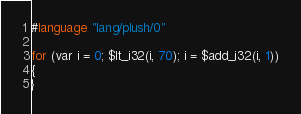Convert code to text. <code><loc_0><loc_0><loc_500><loc_500><_SQL_>#language "lang/plush/0"

for (var i = 0; $lt_i32(i, 70); i = $add_i32(i, 1))
{
}
</code> 